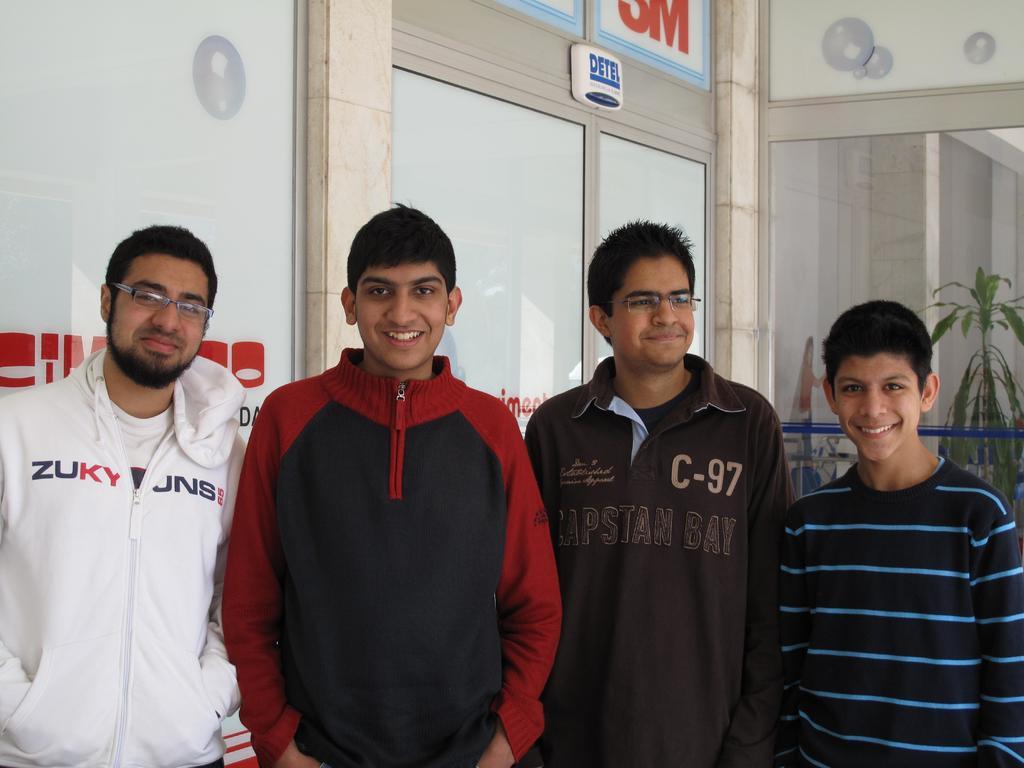What brand is the guy's jacket?
Give a very brief answer. Zuky. What brand does the white hoodie belong to?
Provide a short and direct response. Zuky jns. 